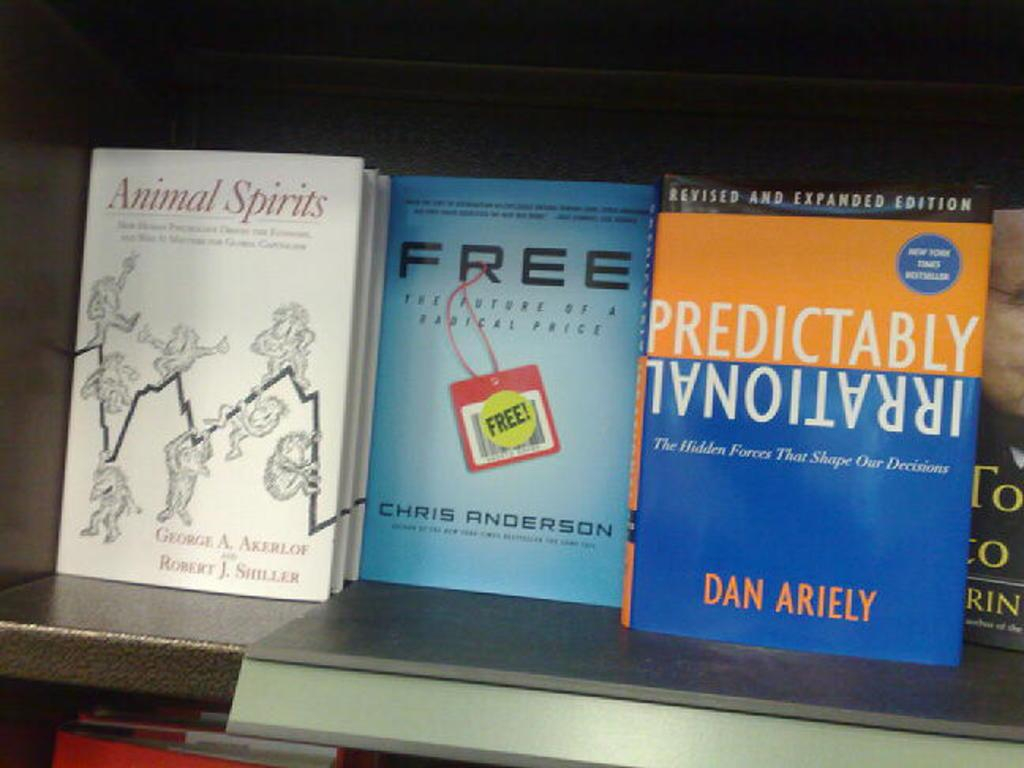<image>
Write a terse but informative summary of the picture. Books displayed on a shelf, one of which is titled "Animal Spirits". 